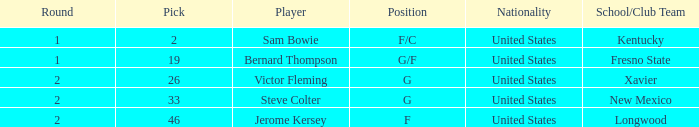What is Nationality, when Position is "G", and when Pick is greater than 26? United States. 